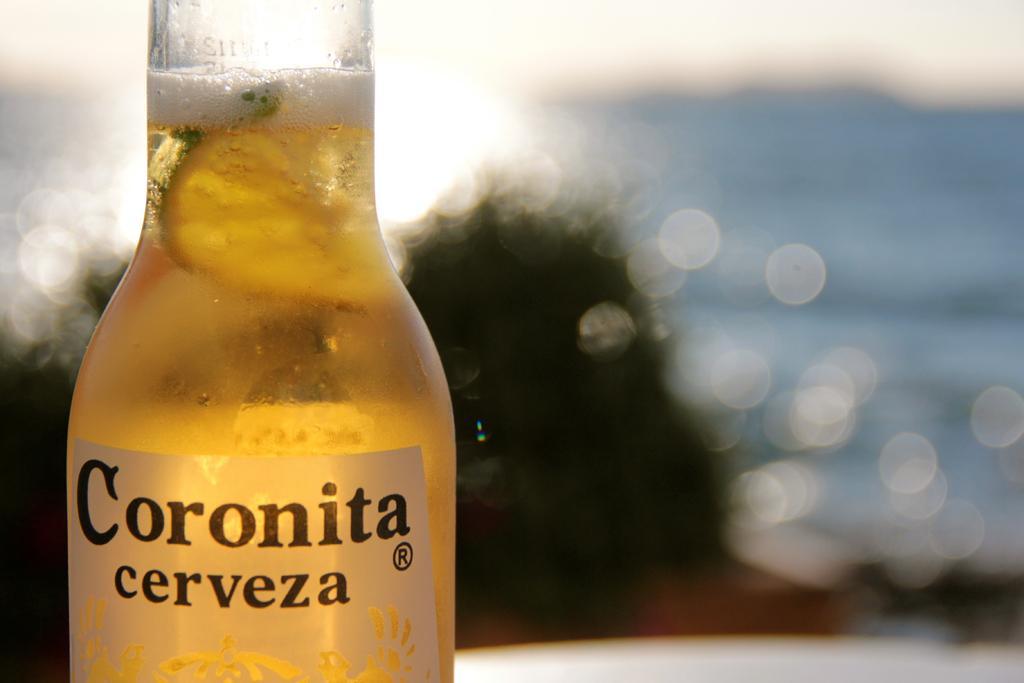Describe this image in one or two sentences. In this image I can see a glass bottle with liquid in it, I can see a print on the bottle and few fruits in the bottle and the foam. In the background I can see water, few trees and the sky. 